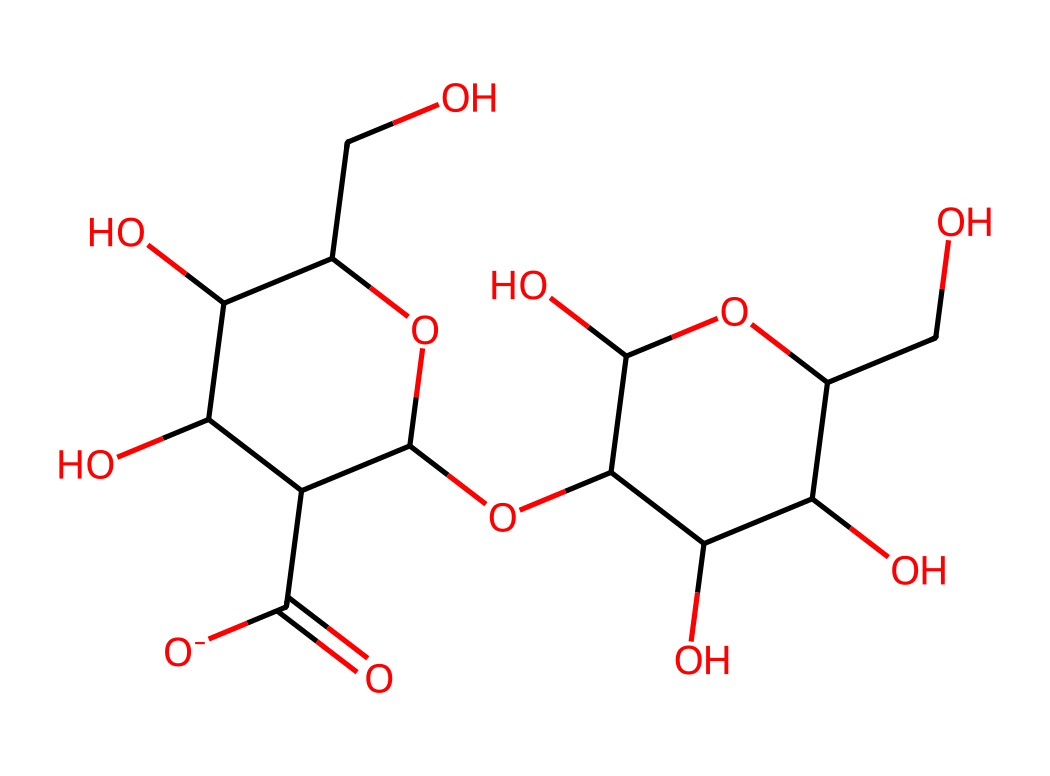What's the main component of cellulose? Cellulose is primarily composed of glucose units linked together through glycosidic bonds.
Answer: glucose How many oxygen atoms are in this structure? By analyzing the SMILES representation, we can count the number of 'O' characters, which corresponds to the oxygen atoms. There are 7 oxygen atoms in the structure.
Answer: 7 What type of bond connects the glucose units in cellulose? The connection between the glucose units is established through glycosidic bonds, which are covalent bonds formed between the hydroxyl groups on adjacent glucose molecules.
Answer: glycosidic bond How many carbon atoms are present in this molecule? The number of carbon atoms can be determined by counting the number of 'C' characters in the SMILES representation. There are 12 carbon atoms in this structure.
Answer: 12 Is cellulose a reducing sugar? Cellulose does not have a free aldehyde or ketone group, which are characteristic of reducing sugars, so it does not react similarly.
Answer: no What is the primary function of cellulose in ancient papyrus? Cellulose provides structural integrity and rigidity to the plant cell walls, making it essential for the strength and durability required in papyrus and other textiles.
Answer: structural integrity 